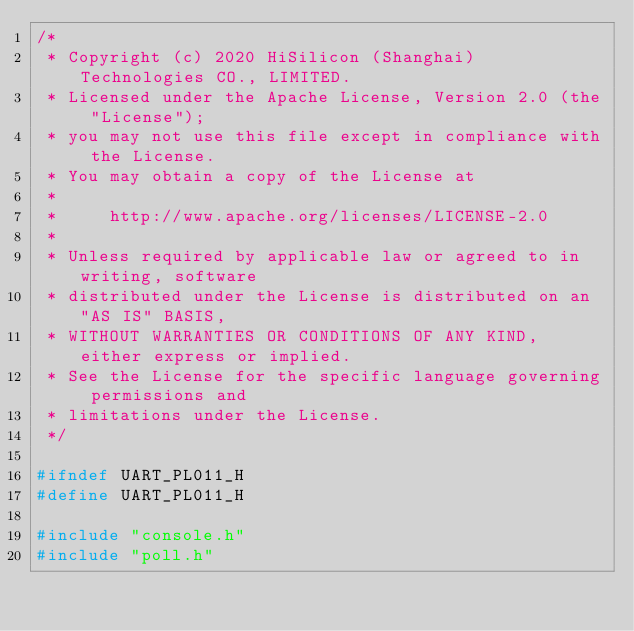Convert code to text. <code><loc_0><loc_0><loc_500><loc_500><_C_>/*
 * Copyright (c) 2020 HiSilicon (Shanghai) Technologies CO., LIMITED.
 * Licensed under the Apache License, Version 2.0 (the "License");
 * you may not use this file except in compliance with the License.
 * You may obtain a copy of the License at
 *
 *     http://www.apache.org/licenses/LICENSE-2.0
 *
 * Unless required by applicable law or agreed to in writing, software
 * distributed under the License is distributed on an "AS IS" BASIS,
 * WITHOUT WARRANTIES OR CONDITIONS OF ANY KIND, either express or implied.
 * See the License for the specific language governing permissions and
 * limitations under the License.
 */

#ifndef UART_PL011_H
#define UART_PL011_H

#include "console.h"
#include "poll.h"</code> 